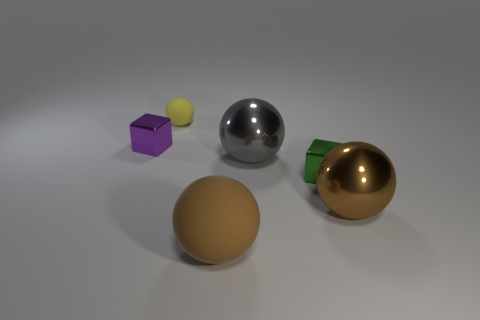Subtract all large rubber spheres. How many spheres are left? 3 Add 4 red rubber cylinders. How many objects exist? 10 Subtract all yellow spheres. How many spheres are left? 3 Subtract all blue spheres. Subtract all purple cubes. How many spheres are left? 4 Subtract all balls. How many objects are left? 2 Subtract all large brown metal things. Subtract all yellow objects. How many objects are left? 4 Add 2 tiny green shiny blocks. How many tiny green shiny blocks are left? 3 Add 5 large brown metallic cylinders. How many large brown metallic cylinders exist? 5 Subtract 0 yellow blocks. How many objects are left? 6 